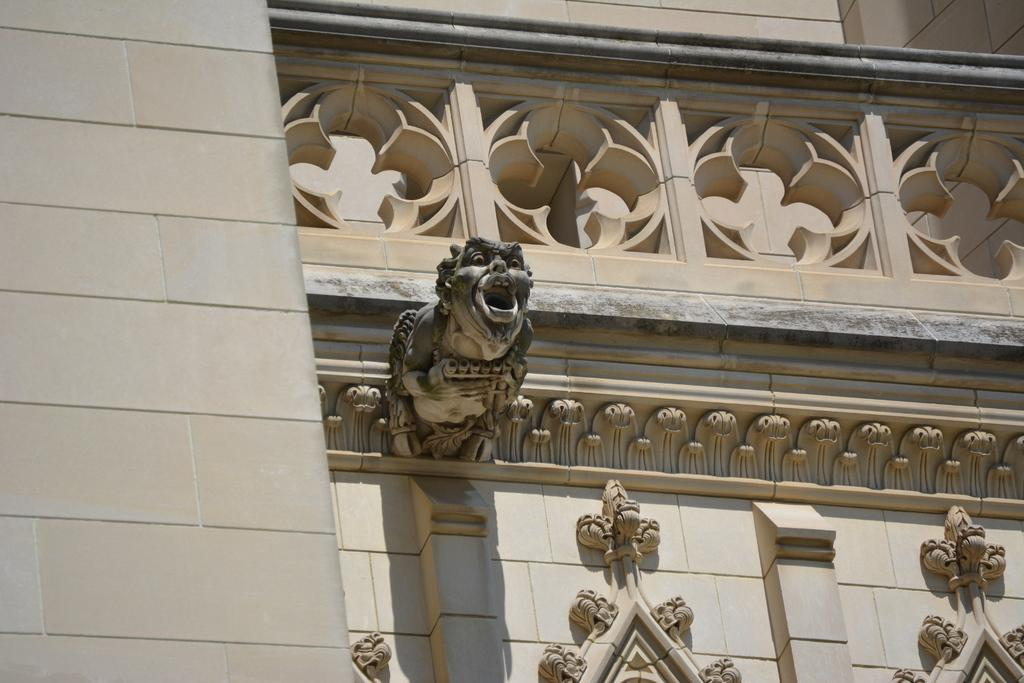What is the main structure visible in the image? There is a building in the image. What decorative elements can be seen on the building? There are sculptures on the wall of the building. How many horses can be seen entering the building through the door in the image? There are no horses or doors present in the image; it only features a building with sculptures on the wall. 